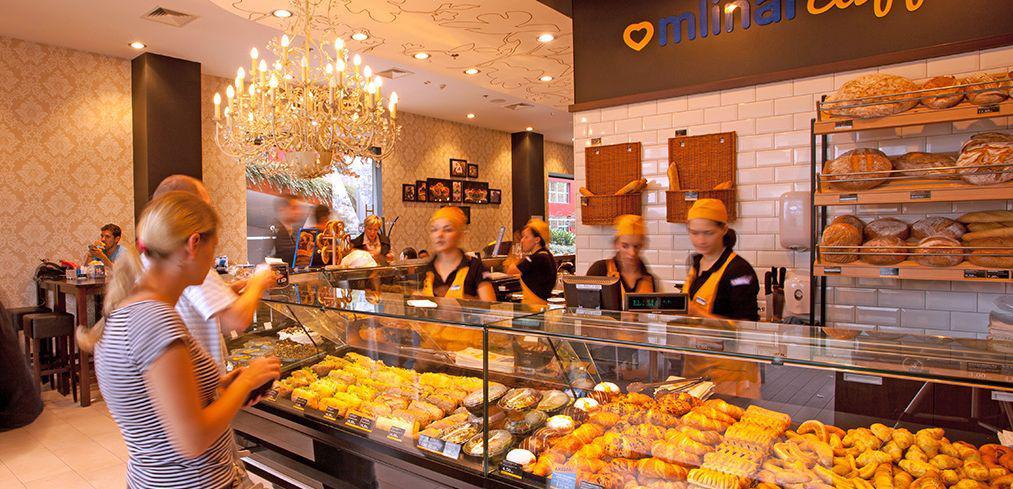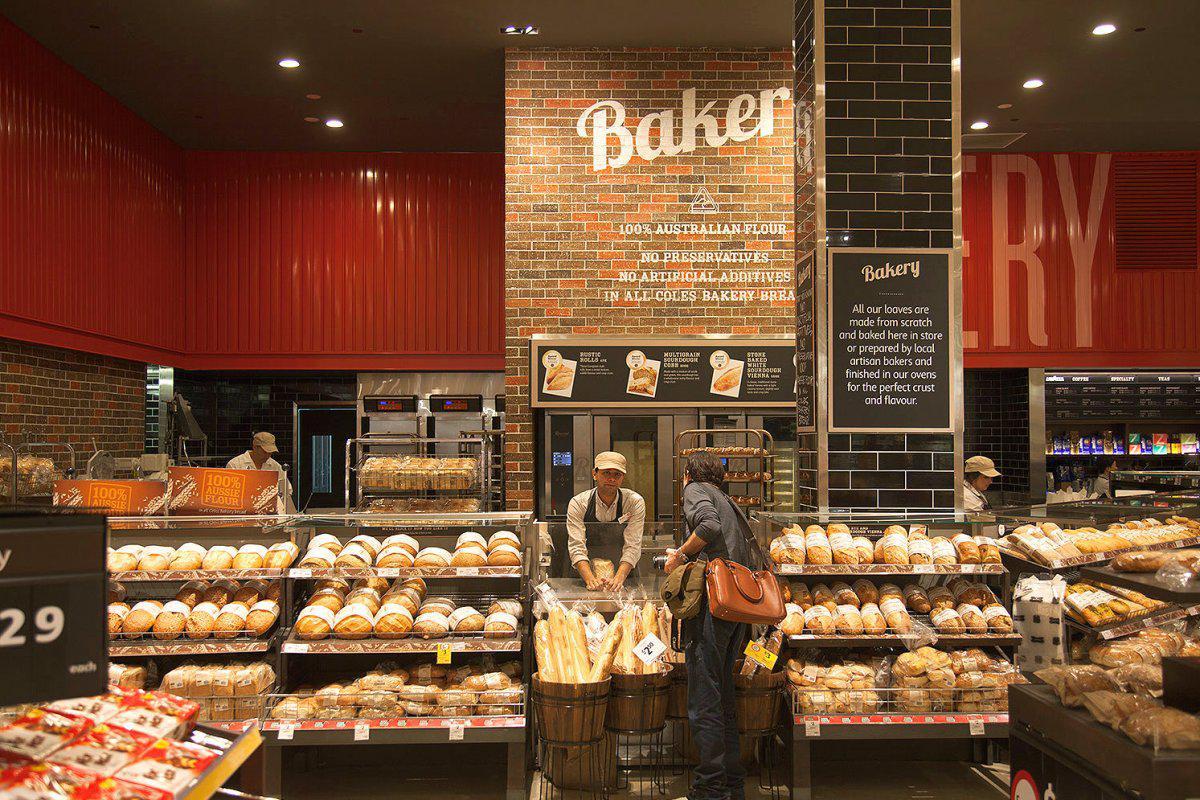The first image is the image on the left, the second image is the image on the right. Considering the images on both sides, is "At least one image shows a uniformed bakery worker." valid? Answer yes or no. Yes. The first image is the image on the left, the second image is the image on the right. Given the left and right images, does the statement "In 1 of the images, a person is near bread." hold true? Answer yes or no. Yes. 